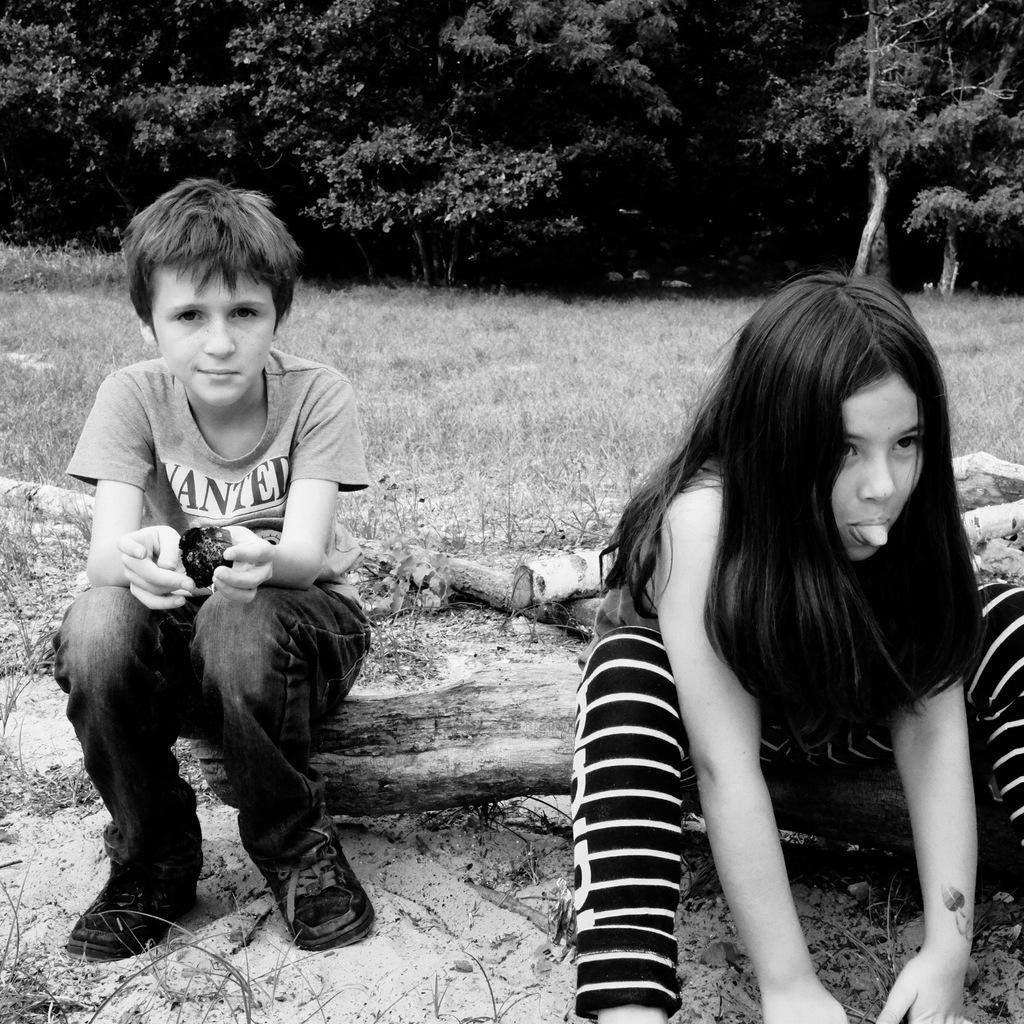Who are the two people in the image? There is a boy and a girl in the image. What are the boy and girl doing in the image? Both the boy and girl are sitting on a tree trunk. What type of terrain is visible in the image? There is grass visible in the image. What can be seen in the background of the image? There are trees in the backdrop of the image. What type of holiday is being celebrated in the image? There is no indication of a holiday being celebrated in the image. Can you provide an example of a similar image with a different setting? The provided facts only describe the image in question, so it's not possible to provide an example of a different image. 